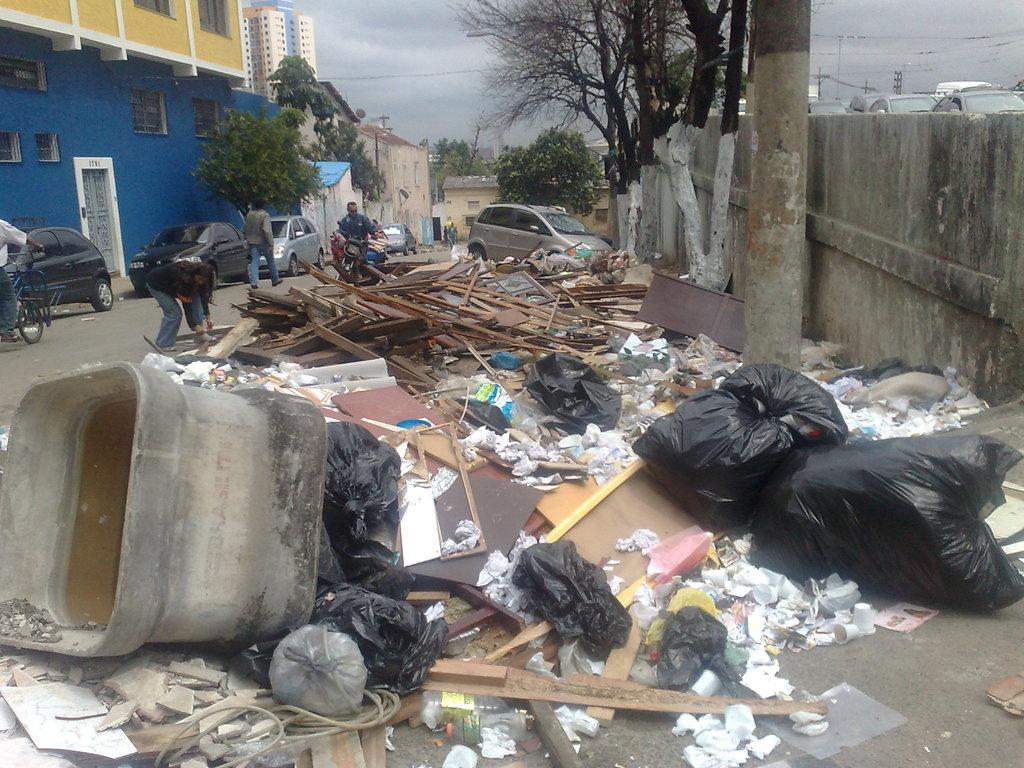What type of objects are present in the image? There are garbage bags, a container, trash, a wall, a pole, and wooden sticks in the image. What is the purpose of the container in the image? The purpose of the container cannot be determined from the image alone. What can be seen in the background of the image? In the background of the image, there are vehicles, poles, trees, people, sky, and buildings. What is the condition of the sky in the image? The sky is cloudy in the image. What type of teaching is being conducted in the image? There is no teaching or educational activity depicted in the image. 